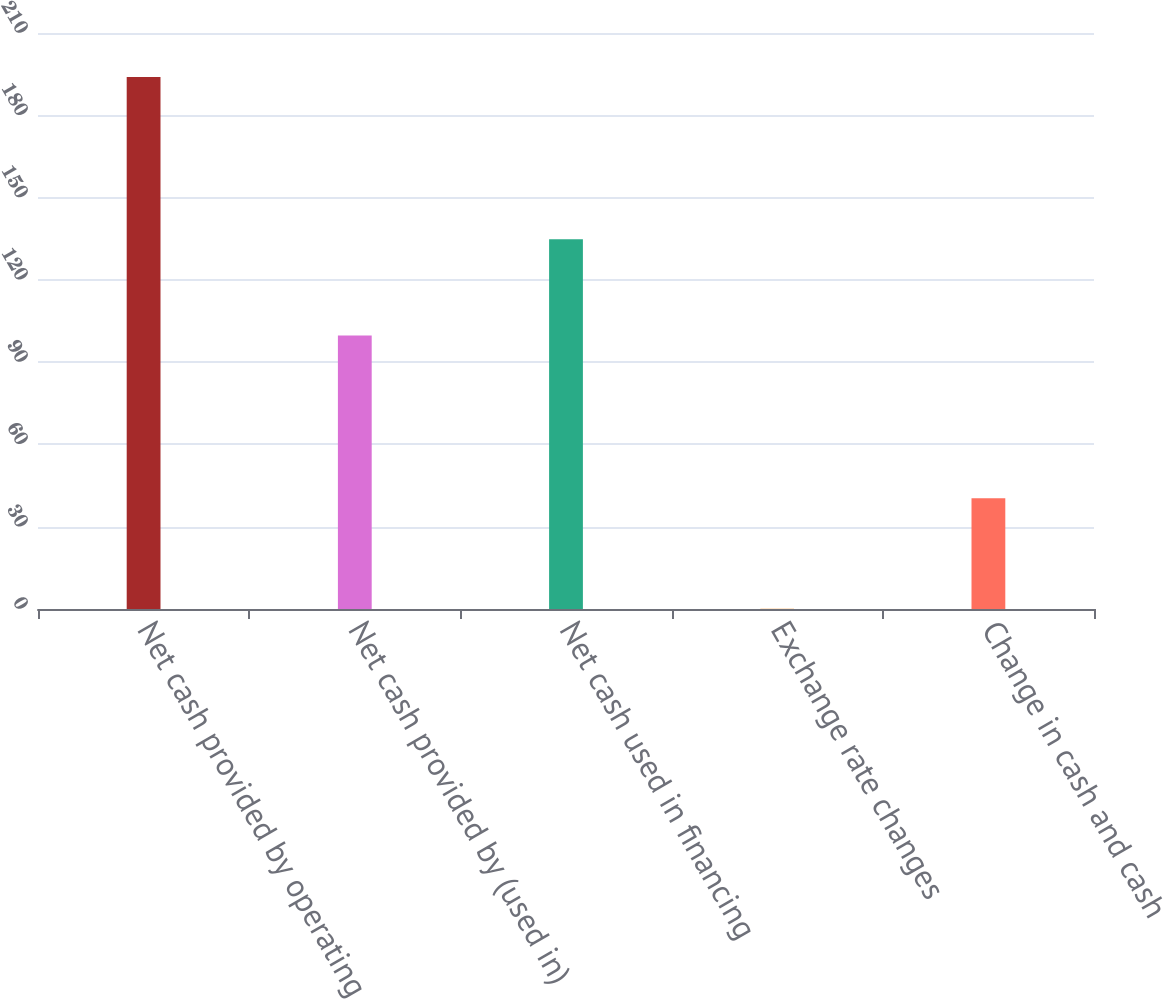Convert chart. <chart><loc_0><loc_0><loc_500><loc_500><bar_chart><fcel>Net cash provided by operating<fcel>Net cash provided by (used in)<fcel>Net cash used in financing<fcel>Exchange rate changes<fcel>Change in cash and cash<nl><fcel>194<fcel>99.7<fcel>134.8<fcel>0.1<fcel>40.4<nl></chart> 